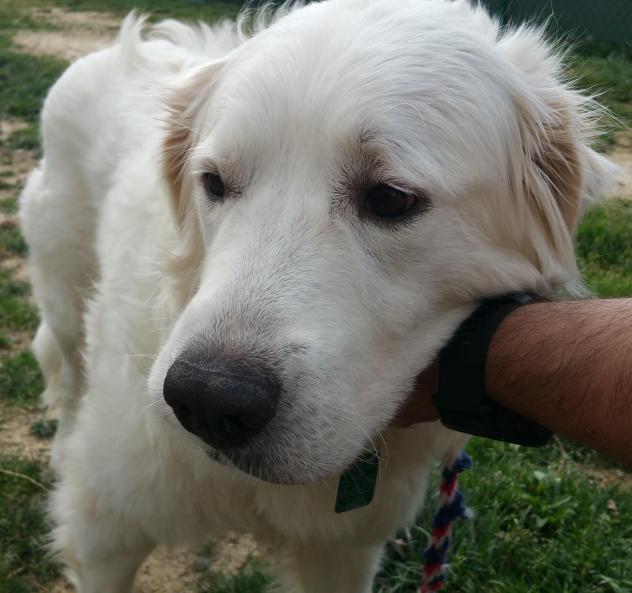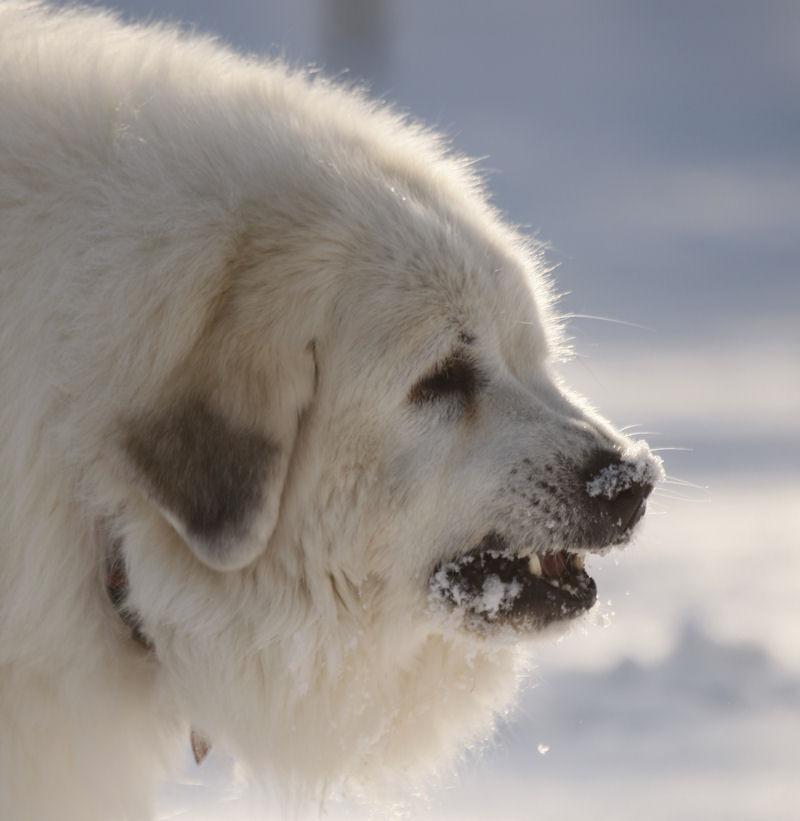The first image is the image on the left, the second image is the image on the right. Examine the images to the left and right. Is the description "The left photo is of a puppy." accurate? Answer yes or no. No. 